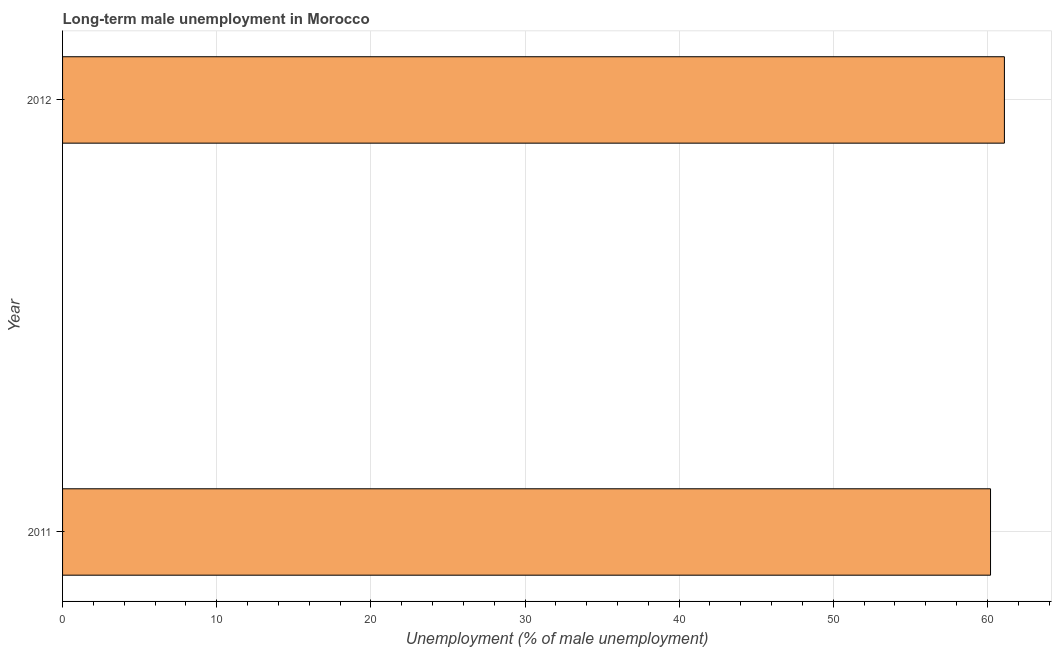Does the graph contain any zero values?
Your response must be concise. No. What is the title of the graph?
Make the answer very short. Long-term male unemployment in Morocco. What is the label or title of the X-axis?
Give a very brief answer. Unemployment (% of male unemployment). What is the long-term male unemployment in 2012?
Provide a short and direct response. 61.1. Across all years, what is the maximum long-term male unemployment?
Keep it short and to the point. 61.1. Across all years, what is the minimum long-term male unemployment?
Ensure brevity in your answer.  60.2. In which year was the long-term male unemployment minimum?
Give a very brief answer. 2011. What is the sum of the long-term male unemployment?
Your answer should be very brief. 121.3. What is the average long-term male unemployment per year?
Your answer should be compact. 60.65. What is the median long-term male unemployment?
Your answer should be compact. 60.65. What is the ratio of the long-term male unemployment in 2011 to that in 2012?
Give a very brief answer. 0.98. Are all the bars in the graph horizontal?
Offer a terse response. Yes. What is the difference between two consecutive major ticks on the X-axis?
Your response must be concise. 10. Are the values on the major ticks of X-axis written in scientific E-notation?
Provide a short and direct response. No. What is the Unemployment (% of male unemployment) of 2011?
Your answer should be very brief. 60.2. What is the Unemployment (% of male unemployment) in 2012?
Offer a very short reply. 61.1. 